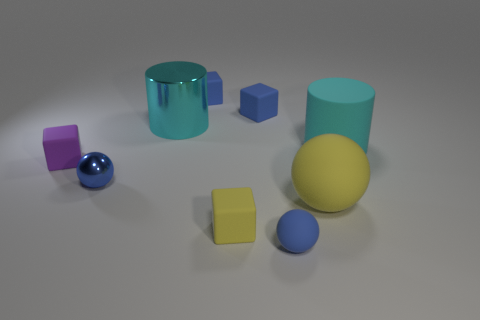Subtract all tiny purple cubes. How many cubes are left? 3 Subtract all red cylinders. How many blue blocks are left? 2 Add 1 blue cubes. How many objects exist? 10 Subtract all yellow blocks. How many blocks are left? 3 Subtract 2 blocks. How many blocks are left? 2 Subtract all purple spheres. Subtract all gray cubes. How many spheres are left? 3 Subtract all blocks. How many objects are left? 5 Subtract all small brown shiny cylinders. Subtract all cyan things. How many objects are left? 7 Add 2 large shiny cylinders. How many large shiny cylinders are left? 3 Add 3 yellow matte balls. How many yellow matte balls exist? 4 